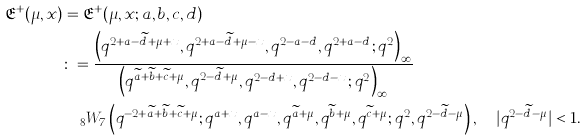Convert formula to latex. <formula><loc_0><loc_0><loc_500><loc_500>\mathfrak { E } ^ { + } ( \mu , x ) & = \mathfrak { E } ^ { + } ( \mu , x ; a , b , c , d ) \\ & \colon = \frac { \left ( q ^ { 2 + a - \widetilde { d } + \mu + x } , q ^ { 2 + a - \widetilde { d } + \mu - x } , q ^ { 2 - a - d } , q ^ { 2 + a - d } ; q ^ { 2 } \right ) _ { \infty } } { \left ( q ^ { \widetilde { a } + \widetilde { b } + \widetilde { c } + \mu } , q ^ { 2 - \widetilde { d } + \mu } , q ^ { 2 - d + x } , q ^ { 2 - d - x } ; q ^ { 2 } \right ) _ { \infty } } \\ & \quad _ { 8 } W _ { 7 } \left ( q ^ { - 2 + \widetilde { a } + \widetilde { b } + \widetilde { c } + \mu } ; q ^ { a + x } , q ^ { a - x } , q ^ { \widetilde { a } + \mu } , q ^ { \widetilde { b } + \mu } , q ^ { \widetilde { c } + \mu } ; q ^ { 2 } , q ^ { 2 - \widetilde { d } - \mu } \right ) , \quad | q ^ { 2 - \widetilde { d } - \mu } | < 1 .</formula> 